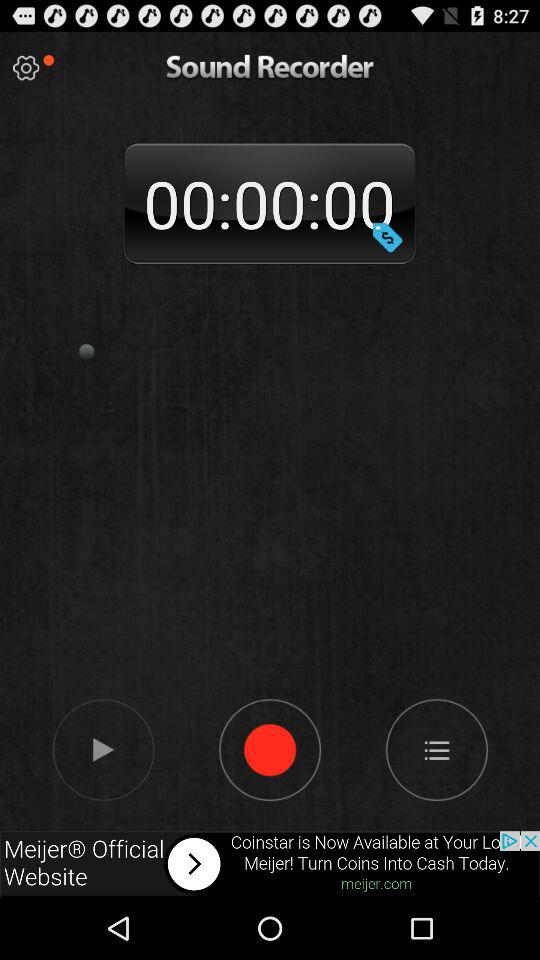What is the name of the recording?
When the provided information is insufficient, respond with <no answer>. <no answer> 